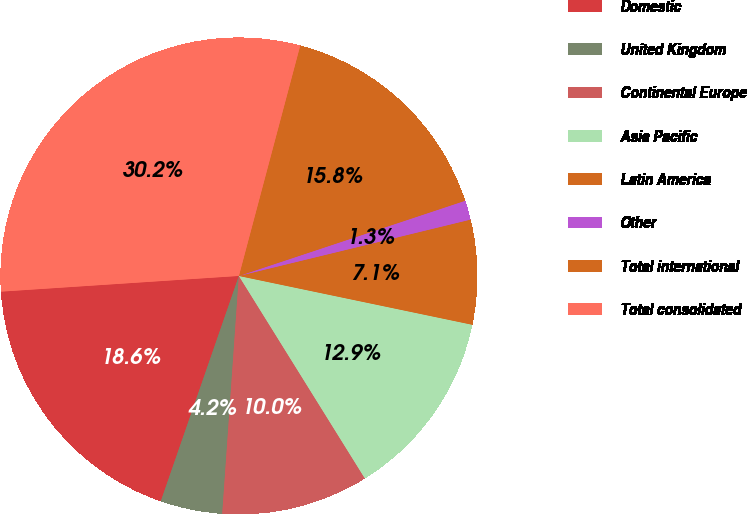Convert chart. <chart><loc_0><loc_0><loc_500><loc_500><pie_chart><fcel>Domestic<fcel>United Kingdom<fcel>Continental Europe<fcel>Asia Pacific<fcel>Latin America<fcel>Other<fcel>Total international<fcel>Total consolidated<nl><fcel>18.64%<fcel>4.2%<fcel>9.97%<fcel>12.86%<fcel>7.08%<fcel>1.31%<fcel>15.75%<fcel>30.19%<nl></chart> 